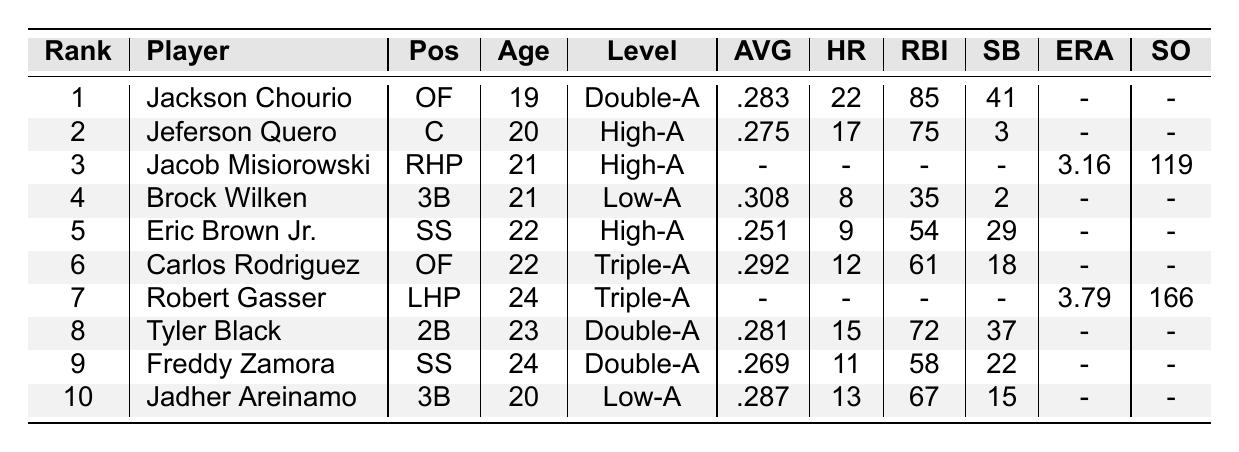What is the batting average of Jackson Chourio? Jackson Chourio is ranked 1st in the table, and his batting average is listed as .283.
Answer: .283 Who has the highest number of home runs among the top 10 prospects? Jackson Chourio has the highest number of home runs with 22, as seen in the 'Home Runs' column.
Answer: 22 Which player has the lowest batting average? Eric Brown Jr. has the lowest batting average at .251 out of all players listed in the table.
Answer: .251 Is Jacob Misiorowski performing in the batting category? Jacob Misiorowski is a pitcher and has no recorded batting statistics; therefore, he does not perform in the batting category.
Answer: No How many RBIs does Tyler Black have compared to Freddy Zamora? Tyler Black has 72 RBIs, while Freddy Zamora has 58 RBIs. The difference is calculated as 72 - 58 = 14.
Answer: 14 Which position has the most players listed in the top 10 prospects? The 'SS' position has two players (Eric Brown Jr. and Freddy Zamora), making it the most populated position among the top 10 prospects.
Answer: SS What is the combined total of stolen bases for Jeferson Quero and Carlos Rodriguez? Jeferson Quero has 3 stolen bases, and Carlos Rodriguez has 18 stolen bases. Adding these together, 3 + 18 = 21.
Answer: 21 Which player has the most strikeouts? Robert Gasser has the most strikeouts at 166, which is the highest value listed under the 'Strikeouts' column.
Answer: 166 How many total home runs do the top 10 prospects hit collectively? The total home runs can be calculated by adding up the home runs of the players who have stats: 22 (Chourio) + 17 (Quero) + 8 (Wilken) + 9 (Brown) + 12 (Rodriguez) + 15 (Black) + 11 (Zamora) + 13 (Areinamo) = 107.
Answer: 107 Are any players listed at the Triple-A level among the top 10 prospects? Yes, both Carlos Rodriguez and Robert Gasser are listed at the Triple-A level.
Answer: Yes 